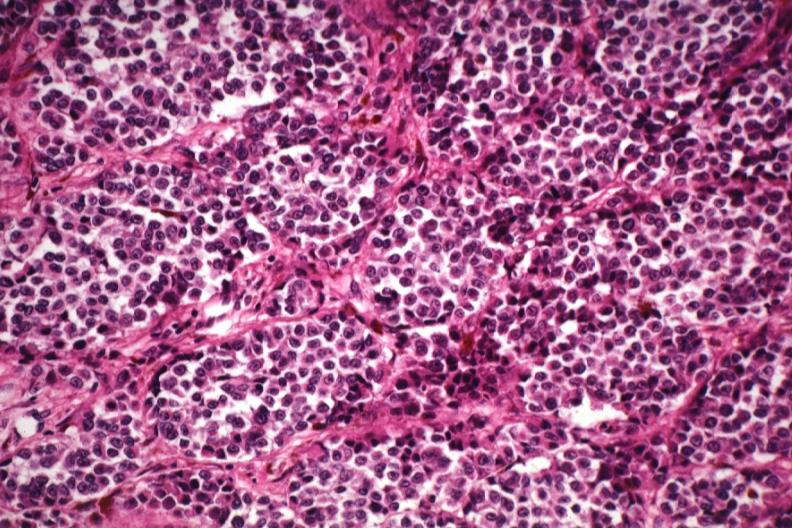where is this?
Answer the question using a single word or phrase. Skin 